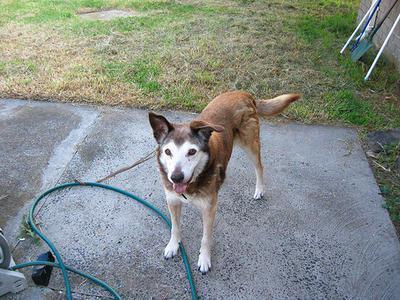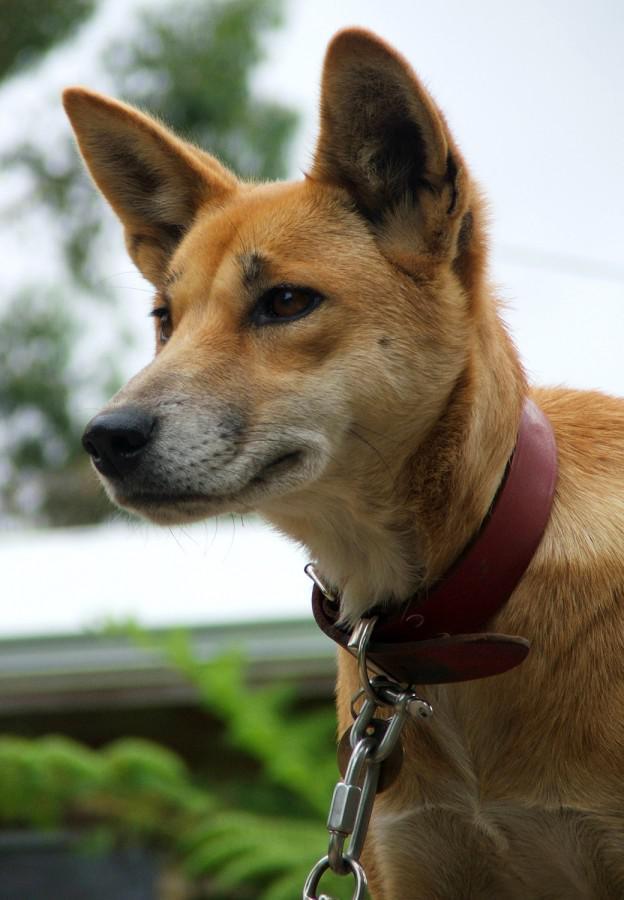The first image is the image on the left, the second image is the image on the right. Considering the images on both sides, is "Only one dog has its mouth open." valid? Answer yes or no. Yes. The first image is the image on the left, the second image is the image on the right. Examine the images to the left and right. Is the description "A dog is standing on all fours on something made of cement." accurate? Answer yes or no. Yes. 